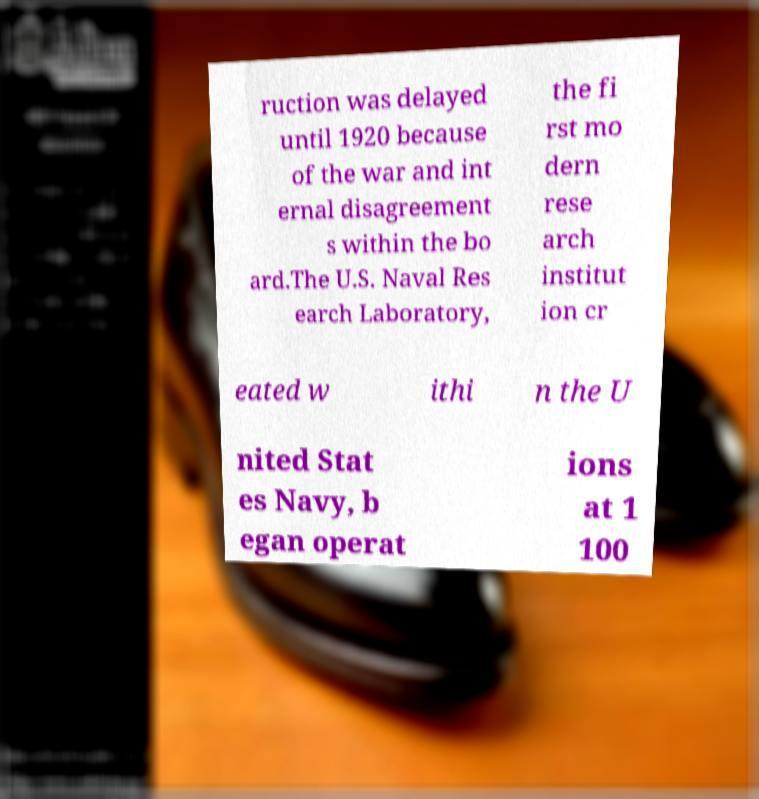Could you assist in decoding the text presented in this image and type it out clearly? ruction was delayed until 1920 because of the war and int ernal disagreement s within the bo ard.The U.S. Naval Res earch Laboratory, the fi rst mo dern rese arch institut ion cr eated w ithi n the U nited Stat es Navy, b egan operat ions at 1 100 